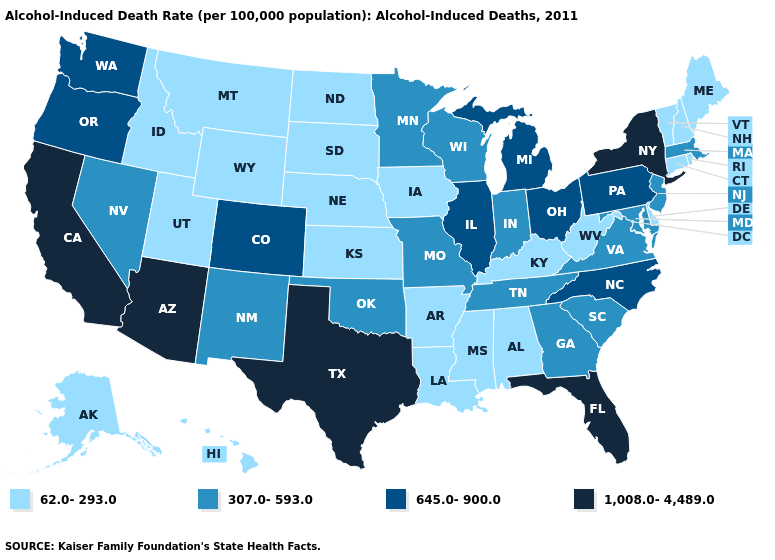What is the value of Nebraska?
Answer briefly. 62.0-293.0. Among the states that border Mississippi , which have the highest value?
Write a very short answer. Tennessee. Which states have the lowest value in the USA?
Write a very short answer. Alabama, Alaska, Arkansas, Connecticut, Delaware, Hawaii, Idaho, Iowa, Kansas, Kentucky, Louisiana, Maine, Mississippi, Montana, Nebraska, New Hampshire, North Dakota, Rhode Island, South Dakota, Utah, Vermont, West Virginia, Wyoming. Among the states that border Oklahoma , which have the lowest value?
Write a very short answer. Arkansas, Kansas. Name the states that have a value in the range 645.0-900.0?
Short answer required. Colorado, Illinois, Michigan, North Carolina, Ohio, Oregon, Pennsylvania, Washington. Is the legend a continuous bar?
Short answer required. No. Among the states that border Missouri , does Arkansas have the lowest value?
Quick response, please. Yes. What is the value of Massachusetts?
Write a very short answer. 307.0-593.0. Name the states that have a value in the range 645.0-900.0?
Short answer required. Colorado, Illinois, Michigan, North Carolina, Ohio, Oregon, Pennsylvania, Washington. Does Michigan have the highest value in the MidWest?
Write a very short answer. Yes. Name the states that have a value in the range 307.0-593.0?
Keep it brief. Georgia, Indiana, Maryland, Massachusetts, Minnesota, Missouri, Nevada, New Jersey, New Mexico, Oklahoma, South Carolina, Tennessee, Virginia, Wisconsin. What is the value of New Hampshire?
Write a very short answer. 62.0-293.0. Name the states that have a value in the range 307.0-593.0?
Answer briefly. Georgia, Indiana, Maryland, Massachusetts, Minnesota, Missouri, Nevada, New Jersey, New Mexico, Oklahoma, South Carolina, Tennessee, Virginia, Wisconsin. Among the states that border Illinois , does Kentucky have the highest value?
Answer briefly. No. Name the states that have a value in the range 645.0-900.0?
Give a very brief answer. Colorado, Illinois, Michigan, North Carolina, Ohio, Oregon, Pennsylvania, Washington. 